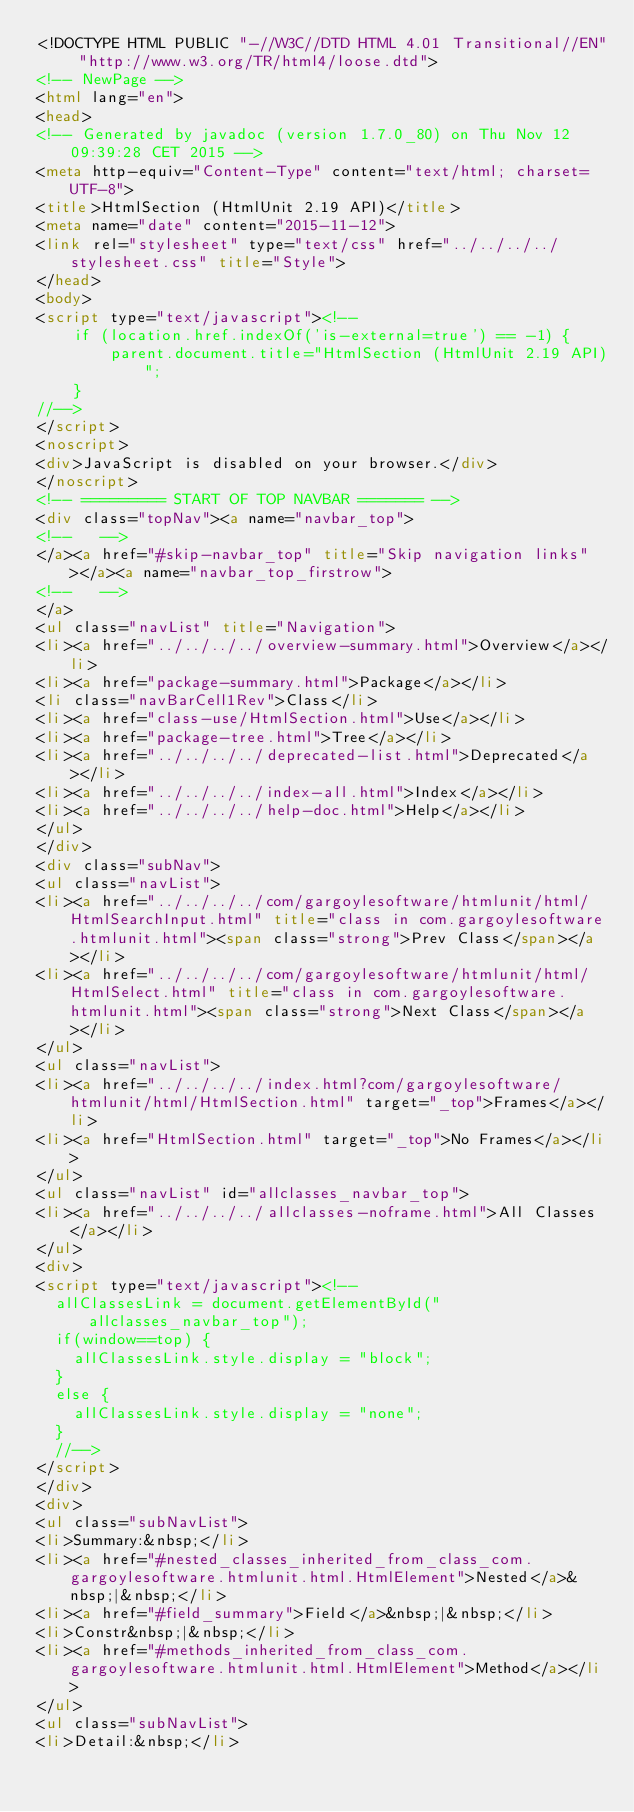<code> <loc_0><loc_0><loc_500><loc_500><_HTML_><!DOCTYPE HTML PUBLIC "-//W3C//DTD HTML 4.01 Transitional//EN" "http://www.w3.org/TR/html4/loose.dtd">
<!-- NewPage -->
<html lang="en">
<head>
<!-- Generated by javadoc (version 1.7.0_80) on Thu Nov 12 09:39:28 CET 2015 -->
<meta http-equiv="Content-Type" content="text/html; charset=UTF-8">
<title>HtmlSection (HtmlUnit 2.19 API)</title>
<meta name="date" content="2015-11-12">
<link rel="stylesheet" type="text/css" href="../../../../stylesheet.css" title="Style">
</head>
<body>
<script type="text/javascript"><!--
    if (location.href.indexOf('is-external=true') == -1) {
        parent.document.title="HtmlSection (HtmlUnit 2.19 API)";
    }
//-->
</script>
<noscript>
<div>JavaScript is disabled on your browser.</div>
</noscript>
<!-- ========= START OF TOP NAVBAR ======= -->
<div class="topNav"><a name="navbar_top">
<!--   -->
</a><a href="#skip-navbar_top" title="Skip navigation links"></a><a name="navbar_top_firstrow">
<!--   -->
</a>
<ul class="navList" title="Navigation">
<li><a href="../../../../overview-summary.html">Overview</a></li>
<li><a href="package-summary.html">Package</a></li>
<li class="navBarCell1Rev">Class</li>
<li><a href="class-use/HtmlSection.html">Use</a></li>
<li><a href="package-tree.html">Tree</a></li>
<li><a href="../../../../deprecated-list.html">Deprecated</a></li>
<li><a href="../../../../index-all.html">Index</a></li>
<li><a href="../../../../help-doc.html">Help</a></li>
</ul>
</div>
<div class="subNav">
<ul class="navList">
<li><a href="../../../../com/gargoylesoftware/htmlunit/html/HtmlSearchInput.html" title="class in com.gargoylesoftware.htmlunit.html"><span class="strong">Prev Class</span></a></li>
<li><a href="../../../../com/gargoylesoftware/htmlunit/html/HtmlSelect.html" title="class in com.gargoylesoftware.htmlunit.html"><span class="strong">Next Class</span></a></li>
</ul>
<ul class="navList">
<li><a href="../../../../index.html?com/gargoylesoftware/htmlunit/html/HtmlSection.html" target="_top">Frames</a></li>
<li><a href="HtmlSection.html" target="_top">No Frames</a></li>
</ul>
<ul class="navList" id="allclasses_navbar_top">
<li><a href="../../../../allclasses-noframe.html">All Classes</a></li>
</ul>
<div>
<script type="text/javascript"><!--
  allClassesLink = document.getElementById("allclasses_navbar_top");
  if(window==top) {
    allClassesLink.style.display = "block";
  }
  else {
    allClassesLink.style.display = "none";
  }
  //-->
</script>
</div>
<div>
<ul class="subNavList">
<li>Summary:&nbsp;</li>
<li><a href="#nested_classes_inherited_from_class_com.gargoylesoftware.htmlunit.html.HtmlElement">Nested</a>&nbsp;|&nbsp;</li>
<li><a href="#field_summary">Field</a>&nbsp;|&nbsp;</li>
<li>Constr&nbsp;|&nbsp;</li>
<li><a href="#methods_inherited_from_class_com.gargoylesoftware.htmlunit.html.HtmlElement">Method</a></li>
</ul>
<ul class="subNavList">
<li>Detail:&nbsp;</li></code> 